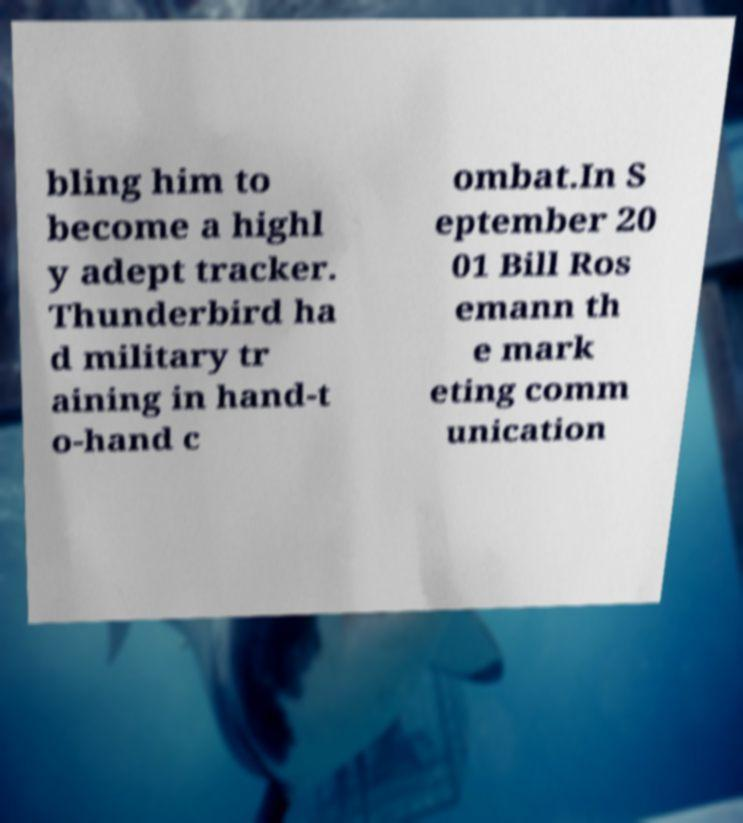What messages or text are displayed in this image? I need them in a readable, typed format. bling him to become a highl y adept tracker. Thunderbird ha d military tr aining in hand-t o-hand c ombat.In S eptember 20 01 Bill Ros emann th e mark eting comm unication 